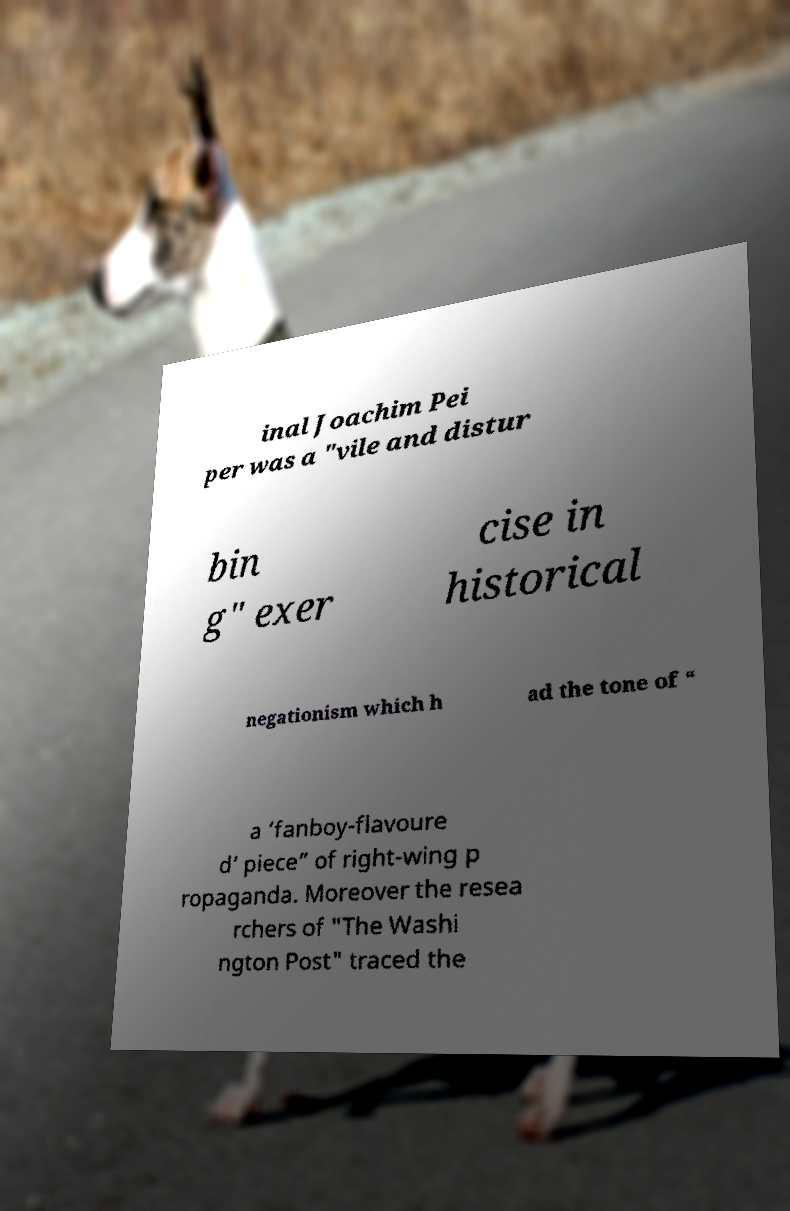What messages or text are displayed in this image? I need them in a readable, typed format. inal Joachim Pei per was a "vile and distur bin g" exer cise in historical negationism which h ad the tone of “ a ‘fanboy-flavoure d’ piece” of right-wing p ropaganda. Moreover the resea rchers of "The Washi ngton Post" traced the 